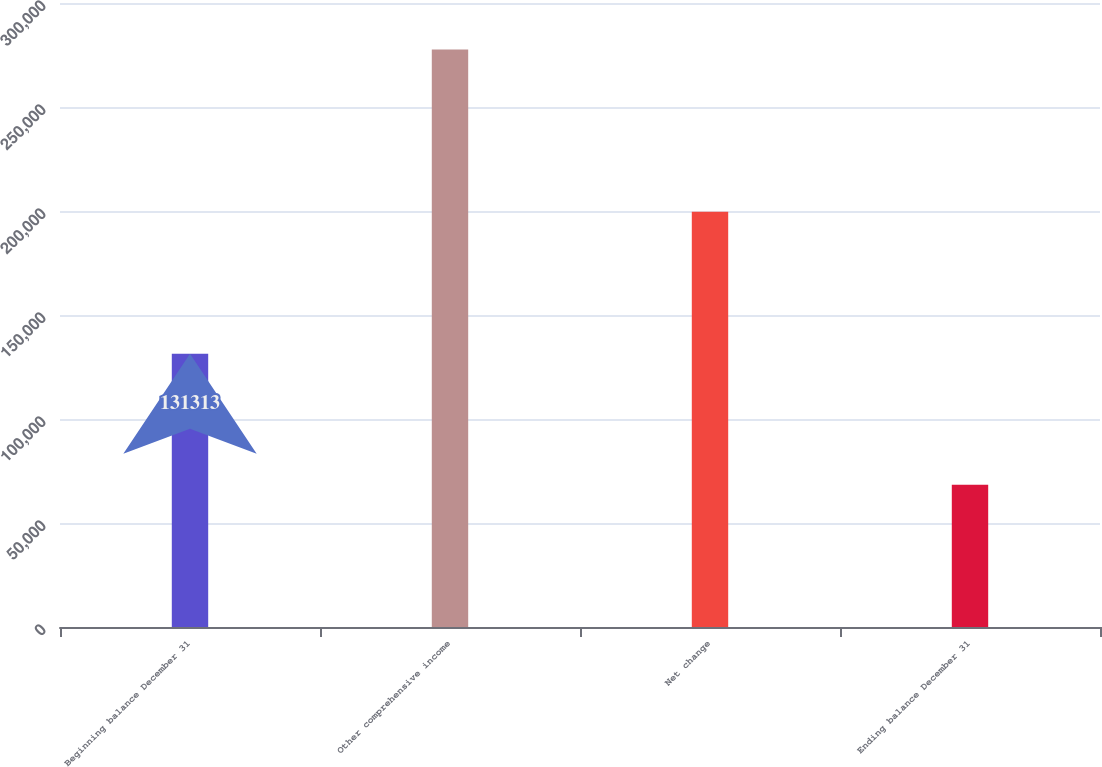<chart> <loc_0><loc_0><loc_500><loc_500><bar_chart><fcel>Beginning balance December 31<fcel>Other comprehensive income<fcel>Net change<fcel>Ending balance December 31<nl><fcel>131313<fcel>277703<fcel>199643<fcel>68330<nl></chart> 